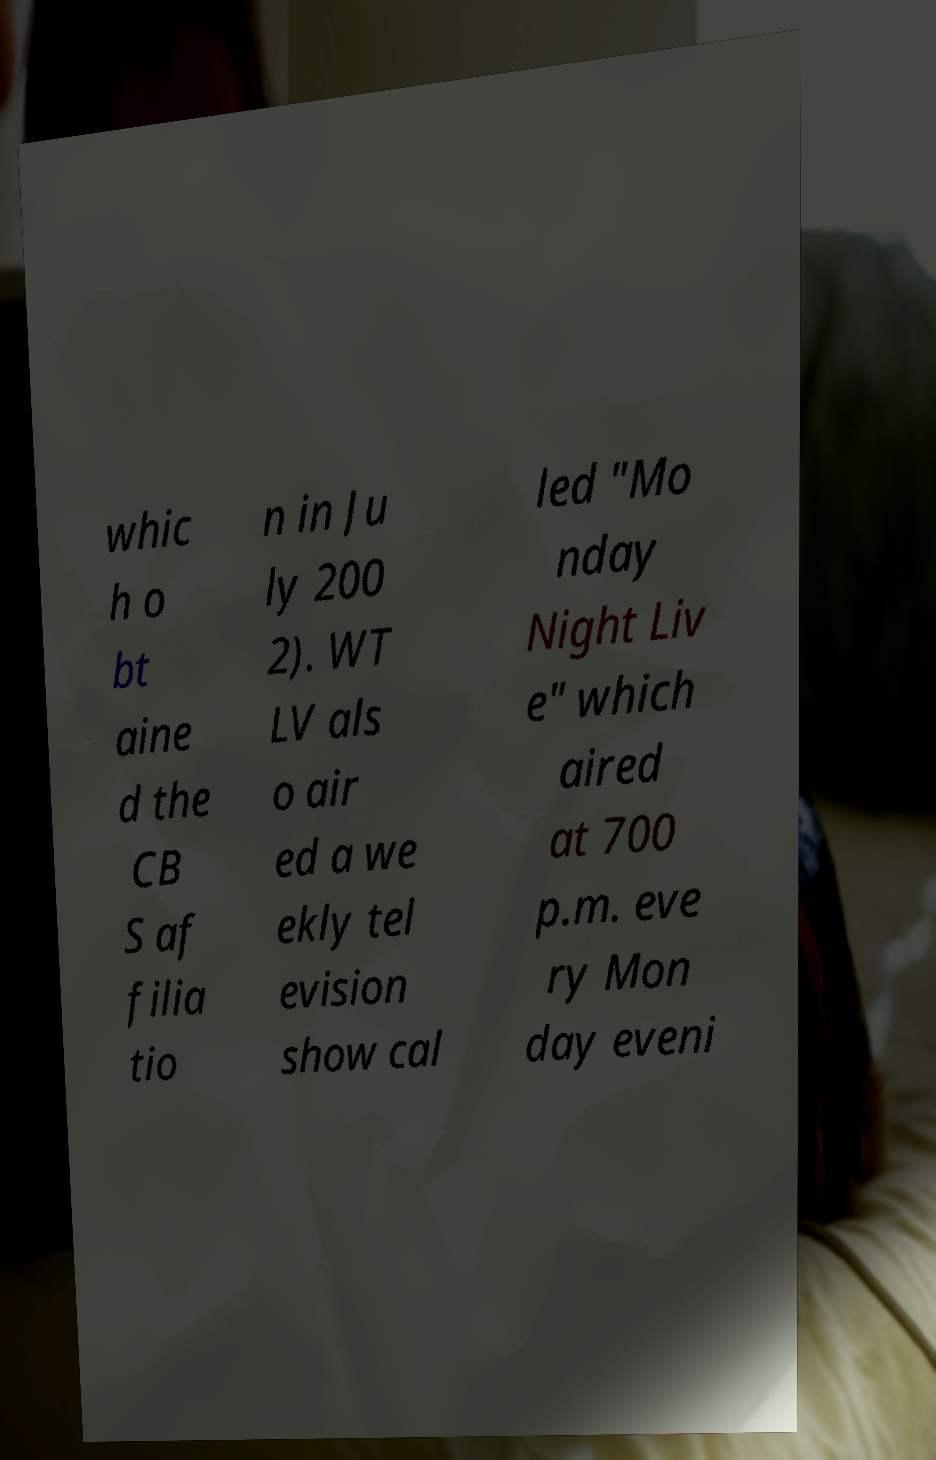Can you read and provide the text displayed in the image?This photo seems to have some interesting text. Can you extract and type it out for me? whic h o bt aine d the CB S af filia tio n in Ju ly 200 2). WT LV als o air ed a we ekly tel evision show cal led "Mo nday Night Liv e" which aired at 700 p.m. eve ry Mon day eveni 